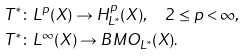Convert formula to latex. <formula><loc_0><loc_0><loc_500><loc_500>T ^ { \ast } & \colon L ^ { p } ( X ) \to H ^ { p } _ { L ^ { \ast } } ( X ) , \quad 2 \leq p < \infty , \\ T ^ { \ast } & \colon L ^ { \infty } ( X ) \to B M O _ { L ^ { \ast } } ( X ) .</formula> 